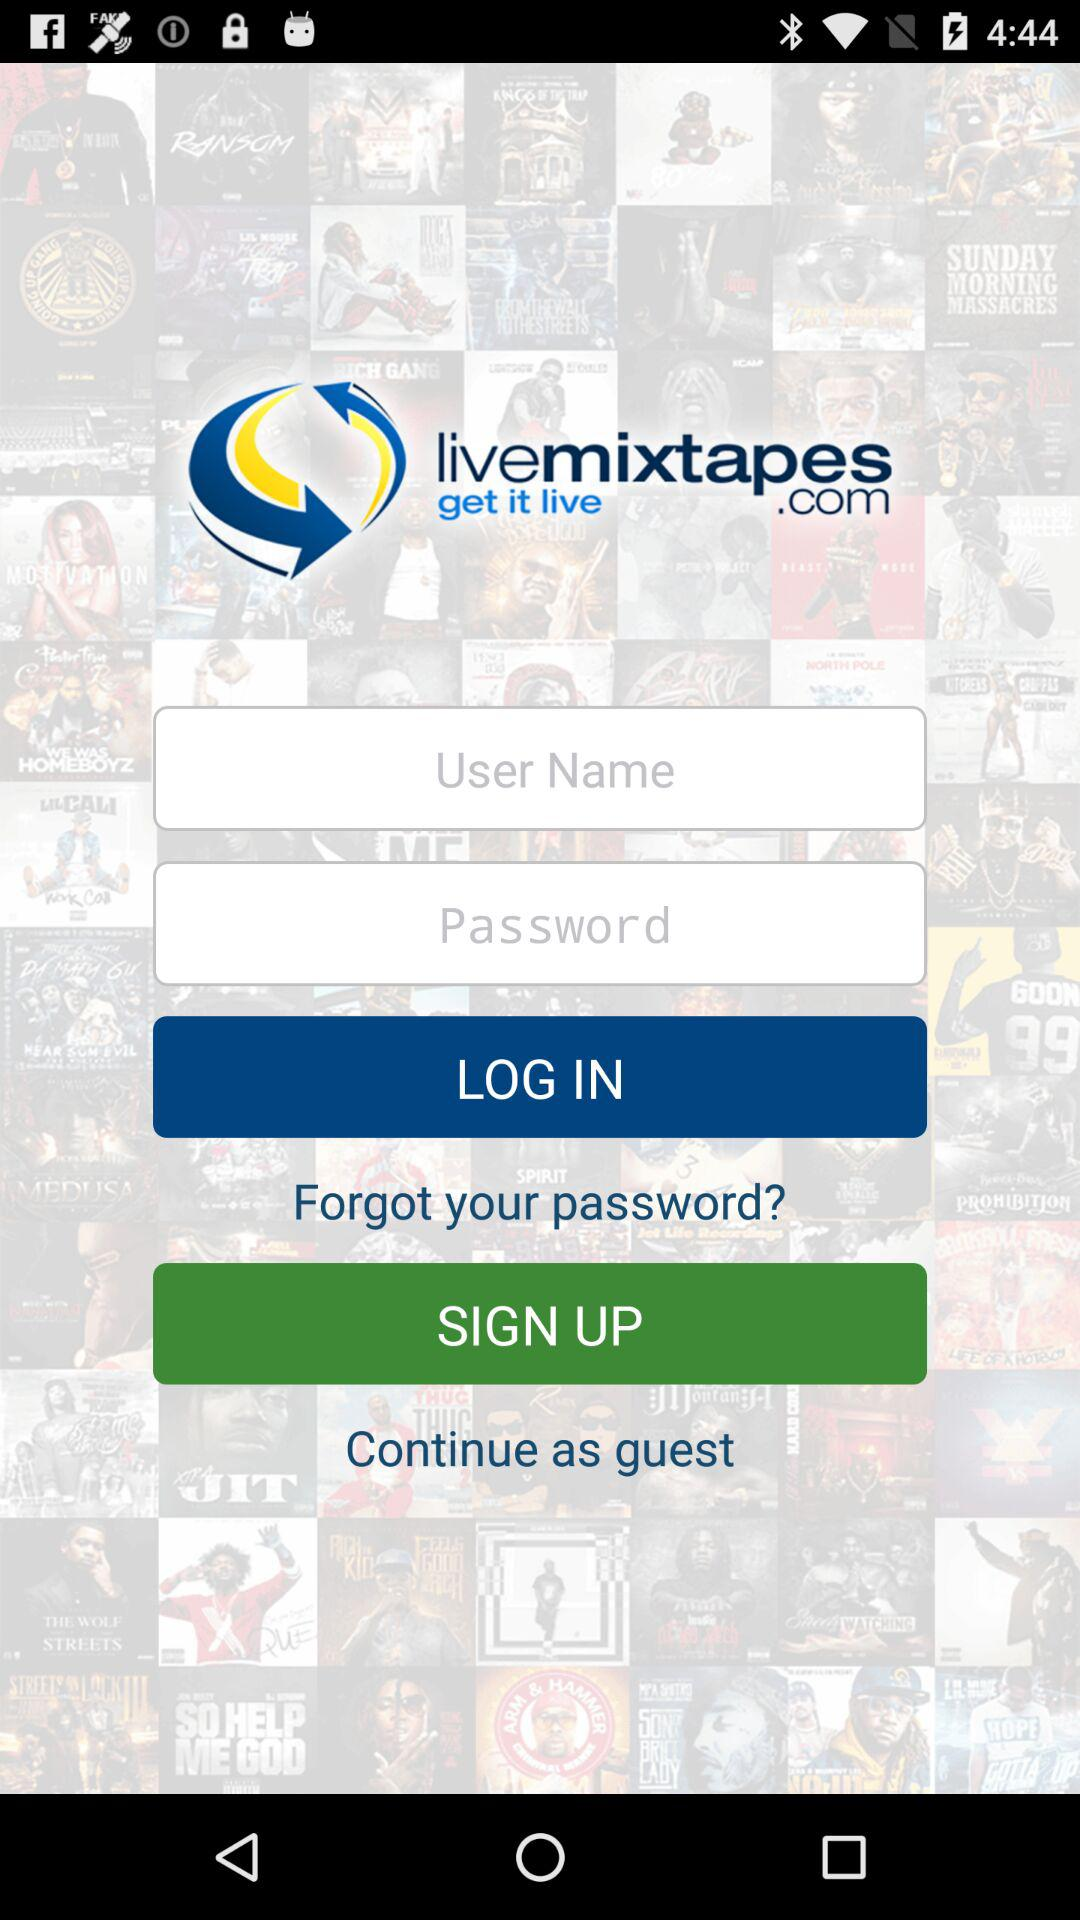What is the application name? The application name is "livemixtapes". 